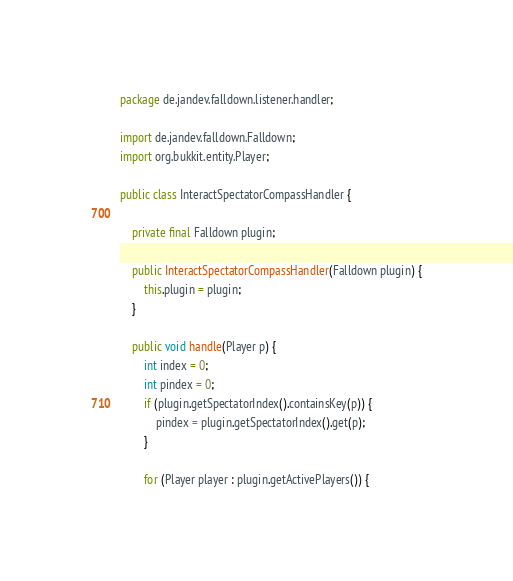Convert code to text. <code><loc_0><loc_0><loc_500><loc_500><_Java_>package de.jandev.falldown.listener.handler;

import de.jandev.falldown.Falldown;
import org.bukkit.entity.Player;

public class InteractSpectatorCompassHandler {

    private final Falldown plugin;

    public InteractSpectatorCompassHandler(Falldown plugin) {
        this.plugin = plugin;
    }

    public void handle(Player p) {
        int index = 0;
        int pindex = 0;
        if (plugin.getSpectatorIndex().containsKey(p)) {
            pindex = plugin.getSpectatorIndex().get(p);
        }

        for (Player player : plugin.getActivePlayers()) {</code> 